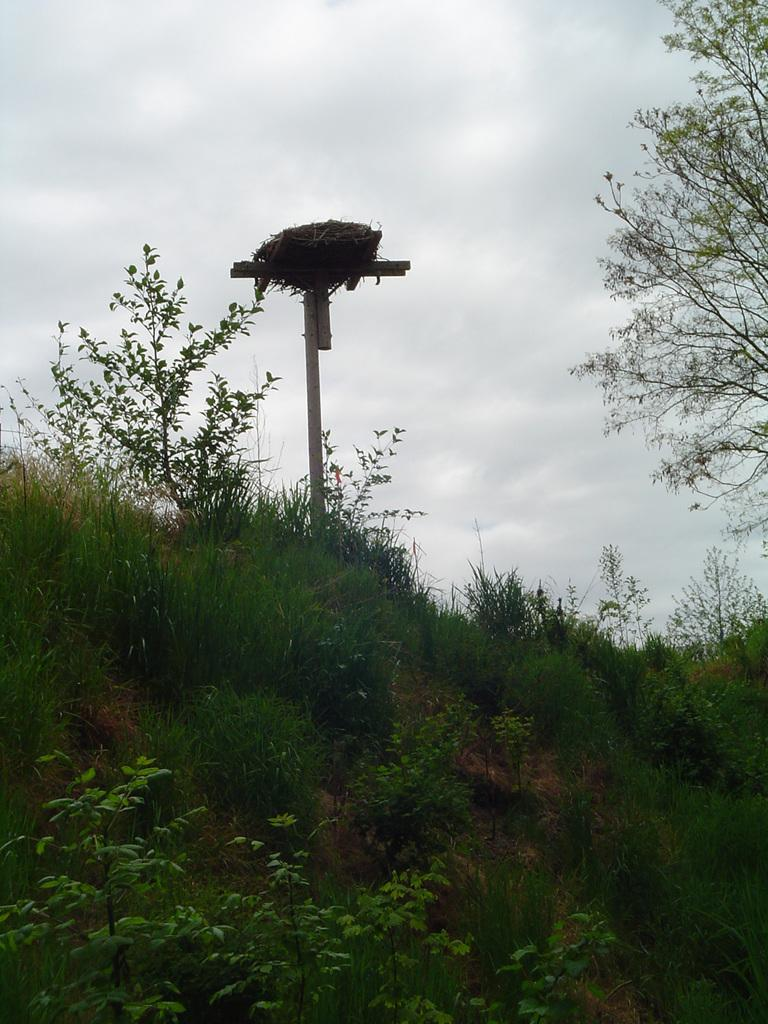What is the dominant feature of the landscape in the image? There is a lot of grass in the image. What other natural elements can be seen in the image? There are plants in the image. What type of object is made of wood and located in the grass? There is a wooden object in the grass. What is the wooden object situated near in the image? There is a tree beside the wooden object. What type of cable can be seen hanging from the tree in the image? There is no cable present in the image; it only features grass, plants, a wooden object, and a tree. 